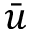Convert formula to latex. <formula><loc_0><loc_0><loc_500><loc_500>\bar { u }</formula> 